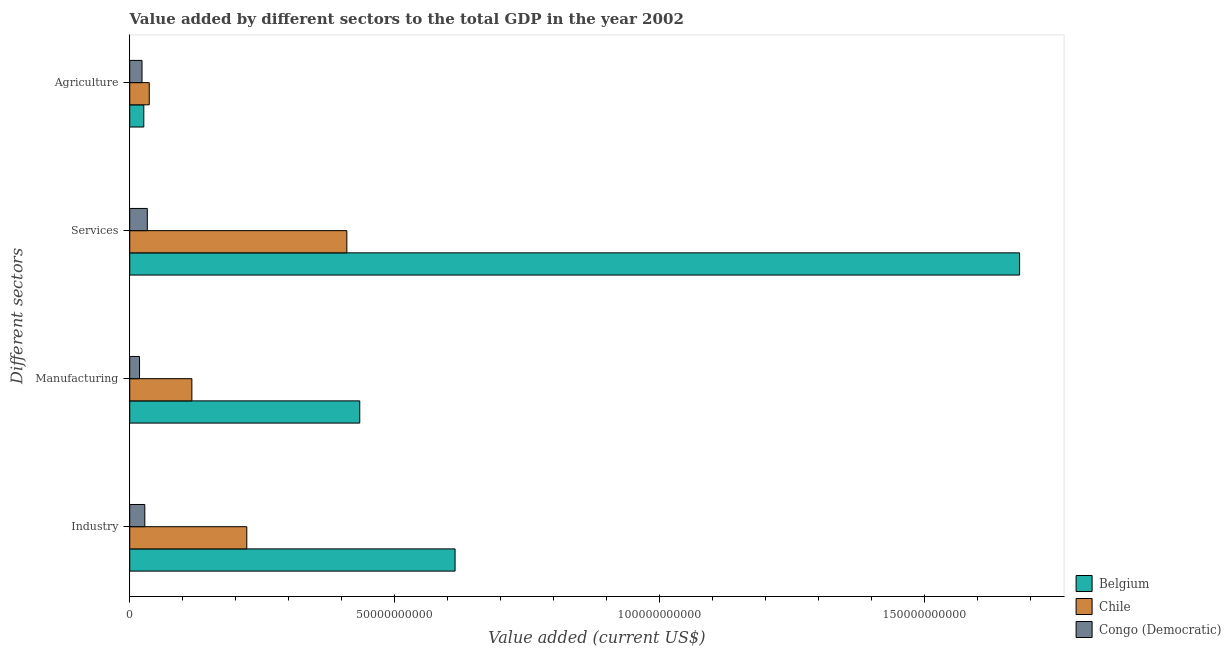How many different coloured bars are there?
Keep it short and to the point. 3. How many groups of bars are there?
Your answer should be compact. 4. Are the number of bars per tick equal to the number of legend labels?
Make the answer very short. Yes. How many bars are there on the 1st tick from the top?
Give a very brief answer. 3. How many bars are there on the 3rd tick from the bottom?
Your answer should be compact. 3. What is the label of the 4th group of bars from the top?
Give a very brief answer. Industry. What is the value added by manufacturing sector in Chile?
Give a very brief answer. 1.17e+1. Across all countries, what is the maximum value added by services sector?
Make the answer very short. 1.68e+11. Across all countries, what is the minimum value added by services sector?
Give a very brief answer. 3.32e+09. In which country was the value added by services sector minimum?
Give a very brief answer. Congo (Democratic). What is the total value added by services sector in the graph?
Keep it short and to the point. 2.12e+11. What is the difference between the value added by industrial sector in Congo (Democratic) and that in Chile?
Your answer should be compact. -1.93e+1. What is the difference between the value added by industrial sector in Congo (Democratic) and the value added by agricultural sector in Belgium?
Your response must be concise. 1.89e+08. What is the average value added by agricultural sector per country?
Provide a short and direct response. 2.89e+09. What is the difference between the value added by agricultural sector and value added by industrial sector in Chile?
Your answer should be very brief. -1.84e+1. What is the ratio of the value added by manufacturing sector in Belgium to that in Congo (Democratic)?
Make the answer very short. 23.45. Is the value added by services sector in Belgium less than that in Chile?
Offer a very short reply. No. What is the difference between the highest and the second highest value added by industrial sector?
Provide a short and direct response. 3.93e+1. What is the difference between the highest and the lowest value added by agricultural sector?
Keep it short and to the point. 1.36e+09. In how many countries, is the value added by services sector greater than the average value added by services sector taken over all countries?
Your answer should be compact. 1. Is the sum of the value added by services sector in Congo (Democratic) and Belgium greater than the maximum value added by industrial sector across all countries?
Your response must be concise. Yes. Is it the case that in every country, the sum of the value added by manufacturing sector and value added by services sector is greater than the sum of value added by agricultural sector and value added by industrial sector?
Ensure brevity in your answer.  No. Are the values on the major ticks of X-axis written in scientific E-notation?
Offer a terse response. No. Where does the legend appear in the graph?
Provide a short and direct response. Bottom right. How are the legend labels stacked?
Provide a short and direct response. Vertical. What is the title of the graph?
Offer a terse response. Value added by different sectors to the total GDP in the year 2002. Does "Palau" appear as one of the legend labels in the graph?
Your answer should be very brief. No. What is the label or title of the X-axis?
Keep it short and to the point. Value added (current US$). What is the label or title of the Y-axis?
Provide a short and direct response. Different sectors. What is the Value added (current US$) in Belgium in Industry?
Offer a terse response. 6.14e+1. What is the Value added (current US$) of Chile in Industry?
Ensure brevity in your answer.  2.21e+1. What is the Value added (current US$) in Congo (Democratic) in Industry?
Provide a short and direct response. 2.85e+09. What is the Value added (current US$) of Belgium in Manufacturing?
Make the answer very short. 4.34e+1. What is the Value added (current US$) of Chile in Manufacturing?
Provide a short and direct response. 1.17e+1. What is the Value added (current US$) in Congo (Democratic) in Manufacturing?
Give a very brief answer. 1.85e+09. What is the Value added (current US$) of Belgium in Services?
Your response must be concise. 1.68e+11. What is the Value added (current US$) of Chile in Services?
Your answer should be very brief. 4.10e+1. What is the Value added (current US$) in Congo (Democratic) in Services?
Your answer should be compact. 3.32e+09. What is the Value added (current US$) in Belgium in Agriculture?
Ensure brevity in your answer.  2.66e+09. What is the Value added (current US$) in Chile in Agriculture?
Your answer should be very brief. 3.69e+09. What is the Value added (current US$) of Congo (Democratic) in Agriculture?
Your answer should be compact. 2.32e+09. Across all Different sectors, what is the maximum Value added (current US$) in Belgium?
Ensure brevity in your answer.  1.68e+11. Across all Different sectors, what is the maximum Value added (current US$) of Chile?
Your answer should be very brief. 4.10e+1. Across all Different sectors, what is the maximum Value added (current US$) of Congo (Democratic)?
Provide a succinct answer. 3.32e+09. Across all Different sectors, what is the minimum Value added (current US$) in Belgium?
Ensure brevity in your answer.  2.66e+09. Across all Different sectors, what is the minimum Value added (current US$) of Chile?
Provide a short and direct response. 3.69e+09. Across all Different sectors, what is the minimum Value added (current US$) of Congo (Democratic)?
Keep it short and to the point. 1.85e+09. What is the total Value added (current US$) in Belgium in the graph?
Your answer should be very brief. 2.75e+11. What is the total Value added (current US$) of Chile in the graph?
Your response must be concise. 7.85e+1. What is the total Value added (current US$) of Congo (Democratic) in the graph?
Your response must be concise. 1.03e+1. What is the difference between the Value added (current US$) of Belgium in Industry and that in Manufacturing?
Offer a very short reply. 1.80e+1. What is the difference between the Value added (current US$) in Chile in Industry and that in Manufacturing?
Provide a succinct answer. 1.04e+1. What is the difference between the Value added (current US$) of Congo (Democratic) in Industry and that in Manufacturing?
Provide a succinct answer. 9.95e+08. What is the difference between the Value added (current US$) in Belgium in Industry and that in Services?
Offer a terse response. -1.07e+11. What is the difference between the Value added (current US$) of Chile in Industry and that in Services?
Keep it short and to the point. -1.89e+1. What is the difference between the Value added (current US$) of Congo (Democratic) in Industry and that in Services?
Give a very brief answer. -4.74e+08. What is the difference between the Value added (current US$) of Belgium in Industry and that in Agriculture?
Your answer should be very brief. 5.88e+1. What is the difference between the Value added (current US$) in Chile in Industry and that in Agriculture?
Provide a short and direct response. 1.84e+1. What is the difference between the Value added (current US$) of Congo (Democratic) in Industry and that in Agriculture?
Give a very brief answer. 5.27e+08. What is the difference between the Value added (current US$) in Belgium in Manufacturing and that in Services?
Provide a succinct answer. -1.25e+11. What is the difference between the Value added (current US$) in Chile in Manufacturing and that in Services?
Give a very brief answer. -2.93e+1. What is the difference between the Value added (current US$) in Congo (Democratic) in Manufacturing and that in Services?
Give a very brief answer. -1.47e+09. What is the difference between the Value added (current US$) in Belgium in Manufacturing and that in Agriculture?
Provide a short and direct response. 4.08e+1. What is the difference between the Value added (current US$) of Chile in Manufacturing and that in Agriculture?
Keep it short and to the point. 8.05e+09. What is the difference between the Value added (current US$) of Congo (Democratic) in Manufacturing and that in Agriculture?
Give a very brief answer. -4.68e+08. What is the difference between the Value added (current US$) of Belgium in Services and that in Agriculture?
Your response must be concise. 1.65e+11. What is the difference between the Value added (current US$) of Chile in Services and that in Agriculture?
Offer a terse response. 3.73e+1. What is the difference between the Value added (current US$) of Congo (Democratic) in Services and that in Agriculture?
Your response must be concise. 1.00e+09. What is the difference between the Value added (current US$) in Belgium in Industry and the Value added (current US$) in Chile in Manufacturing?
Your response must be concise. 4.97e+1. What is the difference between the Value added (current US$) of Belgium in Industry and the Value added (current US$) of Congo (Democratic) in Manufacturing?
Make the answer very short. 5.96e+1. What is the difference between the Value added (current US$) in Chile in Industry and the Value added (current US$) in Congo (Democratic) in Manufacturing?
Your answer should be very brief. 2.02e+1. What is the difference between the Value added (current US$) in Belgium in Industry and the Value added (current US$) in Chile in Services?
Ensure brevity in your answer.  2.04e+1. What is the difference between the Value added (current US$) in Belgium in Industry and the Value added (current US$) in Congo (Democratic) in Services?
Make the answer very short. 5.81e+1. What is the difference between the Value added (current US$) in Chile in Industry and the Value added (current US$) in Congo (Democratic) in Services?
Provide a succinct answer. 1.88e+1. What is the difference between the Value added (current US$) in Belgium in Industry and the Value added (current US$) in Chile in Agriculture?
Your answer should be compact. 5.77e+1. What is the difference between the Value added (current US$) in Belgium in Industry and the Value added (current US$) in Congo (Democratic) in Agriculture?
Offer a very short reply. 5.91e+1. What is the difference between the Value added (current US$) in Chile in Industry and the Value added (current US$) in Congo (Democratic) in Agriculture?
Offer a terse response. 1.98e+1. What is the difference between the Value added (current US$) of Belgium in Manufacturing and the Value added (current US$) of Chile in Services?
Provide a succinct answer. 2.44e+09. What is the difference between the Value added (current US$) in Belgium in Manufacturing and the Value added (current US$) in Congo (Democratic) in Services?
Your answer should be compact. 4.01e+1. What is the difference between the Value added (current US$) in Chile in Manufacturing and the Value added (current US$) in Congo (Democratic) in Services?
Offer a very short reply. 8.41e+09. What is the difference between the Value added (current US$) in Belgium in Manufacturing and the Value added (current US$) in Chile in Agriculture?
Your answer should be compact. 3.97e+1. What is the difference between the Value added (current US$) in Belgium in Manufacturing and the Value added (current US$) in Congo (Democratic) in Agriculture?
Make the answer very short. 4.11e+1. What is the difference between the Value added (current US$) of Chile in Manufacturing and the Value added (current US$) of Congo (Democratic) in Agriculture?
Offer a terse response. 9.41e+09. What is the difference between the Value added (current US$) in Belgium in Services and the Value added (current US$) in Chile in Agriculture?
Ensure brevity in your answer.  1.64e+11. What is the difference between the Value added (current US$) in Belgium in Services and the Value added (current US$) in Congo (Democratic) in Agriculture?
Your answer should be very brief. 1.66e+11. What is the difference between the Value added (current US$) in Chile in Services and the Value added (current US$) in Congo (Democratic) in Agriculture?
Offer a very short reply. 3.87e+1. What is the average Value added (current US$) in Belgium per Different sectors?
Ensure brevity in your answer.  6.89e+1. What is the average Value added (current US$) in Chile per Different sectors?
Offer a terse response. 1.96e+1. What is the average Value added (current US$) of Congo (Democratic) per Different sectors?
Provide a succinct answer. 2.59e+09. What is the difference between the Value added (current US$) of Belgium and Value added (current US$) of Chile in Industry?
Your answer should be compact. 3.93e+1. What is the difference between the Value added (current US$) in Belgium and Value added (current US$) in Congo (Democratic) in Industry?
Offer a very short reply. 5.86e+1. What is the difference between the Value added (current US$) of Chile and Value added (current US$) of Congo (Democratic) in Industry?
Your response must be concise. 1.93e+1. What is the difference between the Value added (current US$) of Belgium and Value added (current US$) of Chile in Manufacturing?
Provide a succinct answer. 3.17e+1. What is the difference between the Value added (current US$) in Belgium and Value added (current US$) in Congo (Democratic) in Manufacturing?
Provide a succinct answer. 4.16e+1. What is the difference between the Value added (current US$) in Chile and Value added (current US$) in Congo (Democratic) in Manufacturing?
Give a very brief answer. 9.88e+09. What is the difference between the Value added (current US$) of Belgium and Value added (current US$) of Chile in Services?
Provide a short and direct response. 1.27e+11. What is the difference between the Value added (current US$) in Belgium and Value added (current US$) in Congo (Democratic) in Services?
Offer a terse response. 1.65e+11. What is the difference between the Value added (current US$) in Chile and Value added (current US$) in Congo (Democratic) in Services?
Ensure brevity in your answer.  3.77e+1. What is the difference between the Value added (current US$) in Belgium and Value added (current US$) in Chile in Agriculture?
Your answer should be compact. -1.03e+09. What is the difference between the Value added (current US$) of Belgium and Value added (current US$) of Congo (Democratic) in Agriculture?
Your answer should be very brief. 3.37e+08. What is the difference between the Value added (current US$) in Chile and Value added (current US$) in Congo (Democratic) in Agriculture?
Keep it short and to the point. 1.36e+09. What is the ratio of the Value added (current US$) of Belgium in Industry to that in Manufacturing?
Offer a terse response. 1.41. What is the ratio of the Value added (current US$) of Chile in Industry to that in Manufacturing?
Offer a very short reply. 1.88. What is the ratio of the Value added (current US$) of Congo (Democratic) in Industry to that in Manufacturing?
Provide a succinct answer. 1.54. What is the ratio of the Value added (current US$) in Belgium in Industry to that in Services?
Offer a very short reply. 0.37. What is the ratio of the Value added (current US$) in Chile in Industry to that in Services?
Your answer should be very brief. 0.54. What is the ratio of the Value added (current US$) of Congo (Democratic) in Industry to that in Services?
Your response must be concise. 0.86. What is the ratio of the Value added (current US$) in Belgium in Industry to that in Agriculture?
Ensure brevity in your answer.  23.11. What is the ratio of the Value added (current US$) of Chile in Industry to that in Agriculture?
Your answer should be compact. 6. What is the ratio of the Value added (current US$) in Congo (Democratic) in Industry to that in Agriculture?
Ensure brevity in your answer.  1.23. What is the ratio of the Value added (current US$) in Belgium in Manufacturing to that in Services?
Offer a very short reply. 0.26. What is the ratio of the Value added (current US$) of Chile in Manufacturing to that in Services?
Give a very brief answer. 0.29. What is the ratio of the Value added (current US$) of Congo (Democratic) in Manufacturing to that in Services?
Your answer should be very brief. 0.56. What is the ratio of the Value added (current US$) of Belgium in Manufacturing to that in Agriculture?
Give a very brief answer. 16.34. What is the ratio of the Value added (current US$) of Chile in Manufacturing to that in Agriculture?
Give a very brief answer. 3.18. What is the ratio of the Value added (current US$) in Congo (Democratic) in Manufacturing to that in Agriculture?
Your response must be concise. 0.8. What is the ratio of the Value added (current US$) of Belgium in Services to that in Agriculture?
Provide a succinct answer. 63.21. What is the ratio of the Value added (current US$) of Chile in Services to that in Agriculture?
Your answer should be compact. 11.12. What is the ratio of the Value added (current US$) of Congo (Democratic) in Services to that in Agriculture?
Offer a terse response. 1.43. What is the difference between the highest and the second highest Value added (current US$) of Belgium?
Your answer should be very brief. 1.07e+11. What is the difference between the highest and the second highest Value added (current US$) of Chile?
Provide a short and direct response. 1.89e+1. What is the difference between the highest and the second highest Value added (current US$) of Congo (Democratic)?
Give a very brief answer. 4.74e+08. What is the difference between the highest and the lowest Value added (current US$) in Belgium?
Ensure brevity in your answer.  1.65e+11. What is the difference between the highest and the lowest Value added (current US$) of Chile?
Keep it short and to the point. 3.73e+1. What is the difference between the highest and the lowest Value added (current US$) of Congo (Democratic)?
Your answer should be very brief. 1.47e+09. 